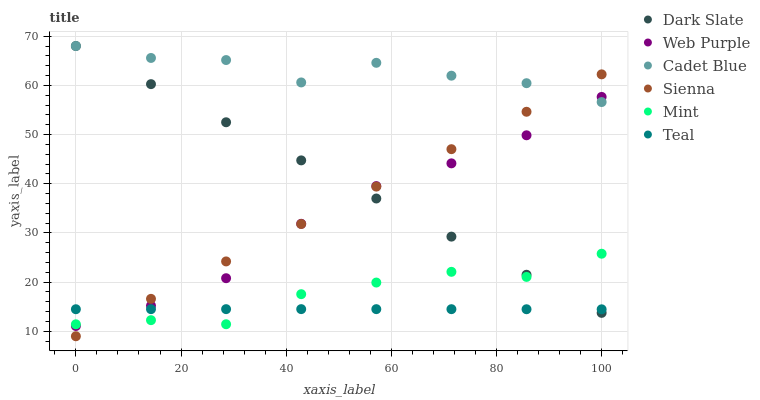Does Teal have the minimum area under the curve?
Answer yes or no. Yes. Does Cadet Blue have the maximum area under the curve?
Answer yes or no. Yes. Does Sienna have the minimum area under the curve?
Answer yes or no. No. Does Sienna have the maximum area under the curve?
Answer yes or no. No. Is Sienna the smoothest?
Answer yes or no. Yes. Is Cadet Blue the roughest?
Answer yes or no. Yes. Is Dark Slate the smoothest?
Answer yes or no. No. Is Dark Slate the roughest?
Answer yes or no. No. Does Sienna have the lowest value?
Answer yes or no. Yes. Does Dark Slate have the lowest value?
Answer yes or no. No. Does Dark Slate have the highest value?
Answer yes or no. Yes. Does Sienna have the highest value?
Answer yes or no. No. Is Mint less than Cadet Blue?
Answer yes or no. Yes. Is Cadet Blue greater than Teal?
Answer yes or no. Yes. Does Sienna intersect Teal?
Answer yes or no. Yes. Is Sienna less than Teal?
Answer yes or no. No. Is Sienna greater than Teal?
Answer yes or no. No. Does Mint intersect Cadet Blue?
Answer yes or no. No. 